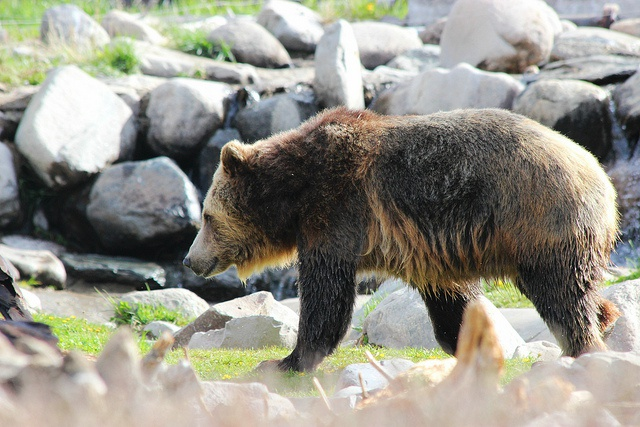Describe the objects in this image and their specific colors. I can see a bear in darkgray, black, and gray tones in this image. 